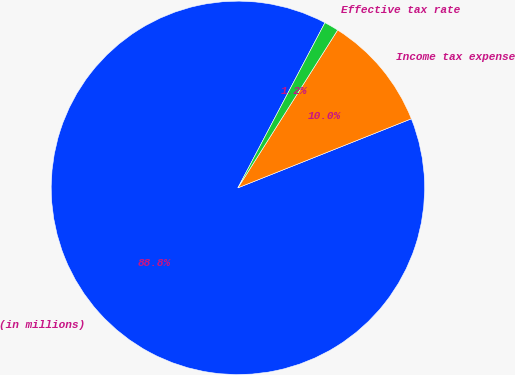Convert chart to OTSL. <chart><loc_0><loc_0><loc_500><loc_500><pie_chart><fcel>(in millions)<fcel>Income tax expense<fcel>Effective tax rate<nl><fcel>88.75%<fcel>10.0%<fcel>1.25%<nl></chart> 